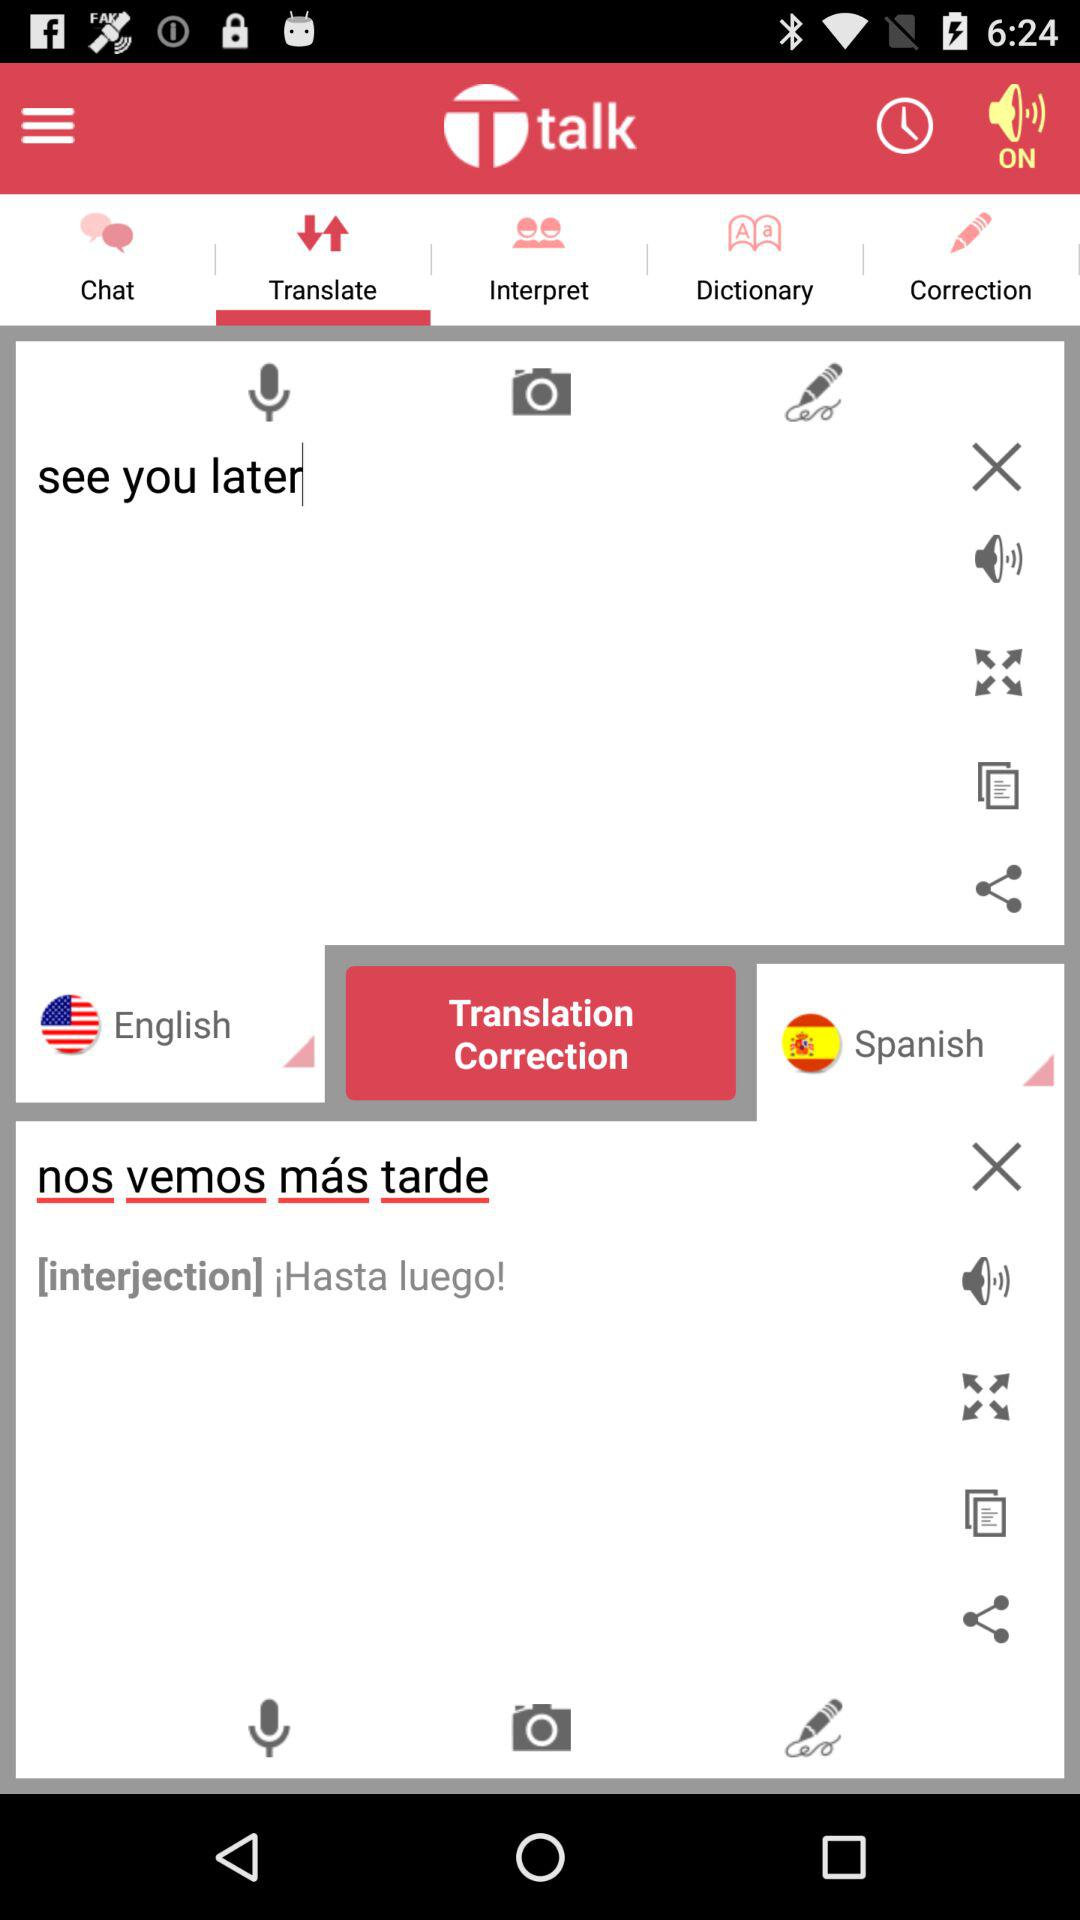Which language has been translated? The language that has been translated is English. 